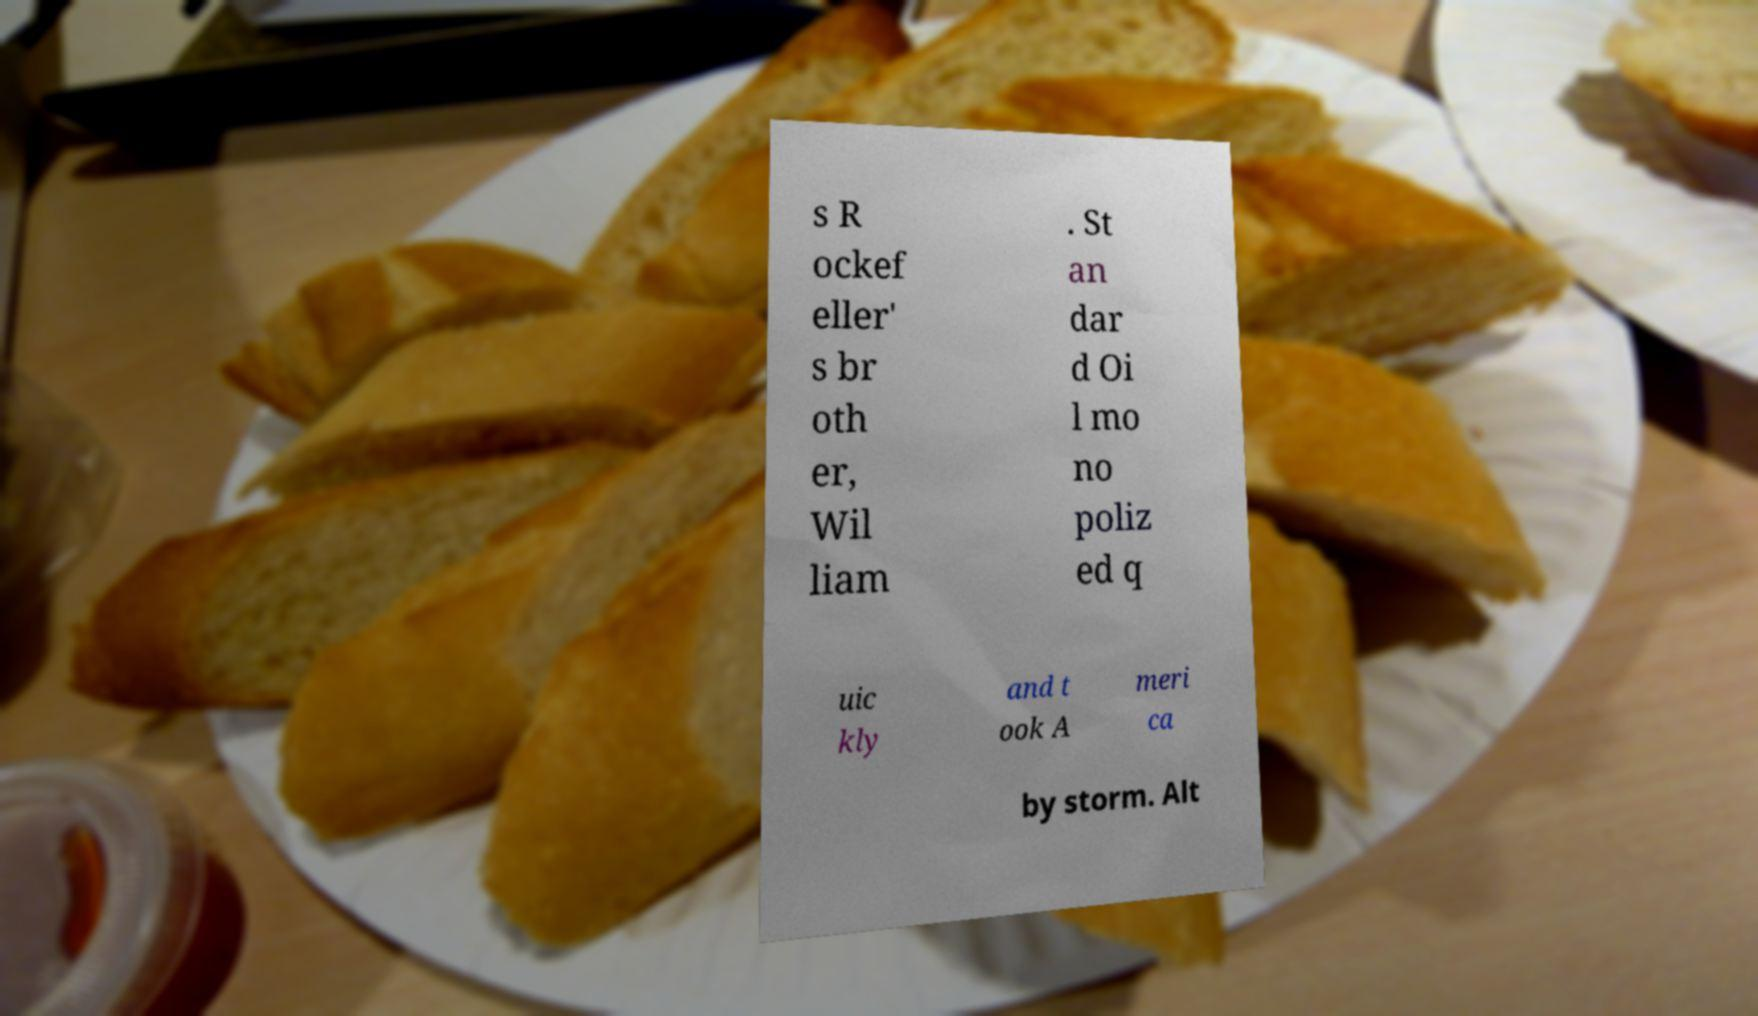Can you accurately transcribe the text from the provided image for me? s R ockef eller' s br oth er, Wil liam . St an dar d Oi l mo no poliz ed q uic kly and t ook A meri ca by storm. Alt 